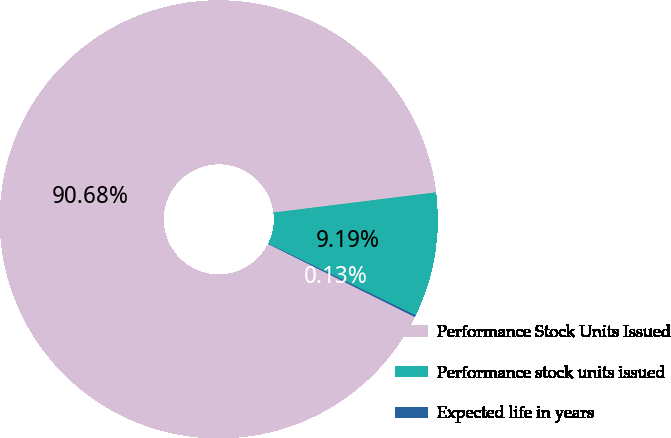Convert chart. <chart><loc_0><loc_0><loc_500><loc_500><pie_chart><fcel>Performance Stock Units Issued<fcel>Performance stock units issued<fcel>Expected life in years<nl><fcel>90.68%<fcel>9.19%<fcel>0.13%<nl></chart> 